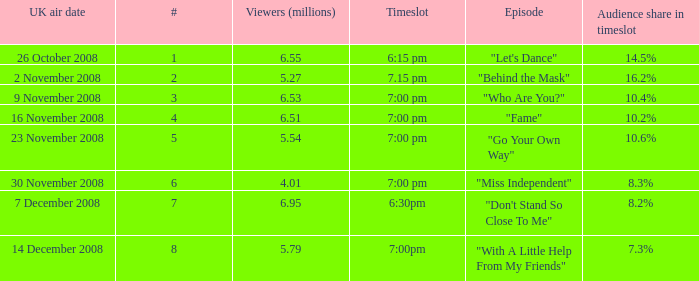Name the uk air date for audience share in timeslot in 7.3% 14 December 2008. 